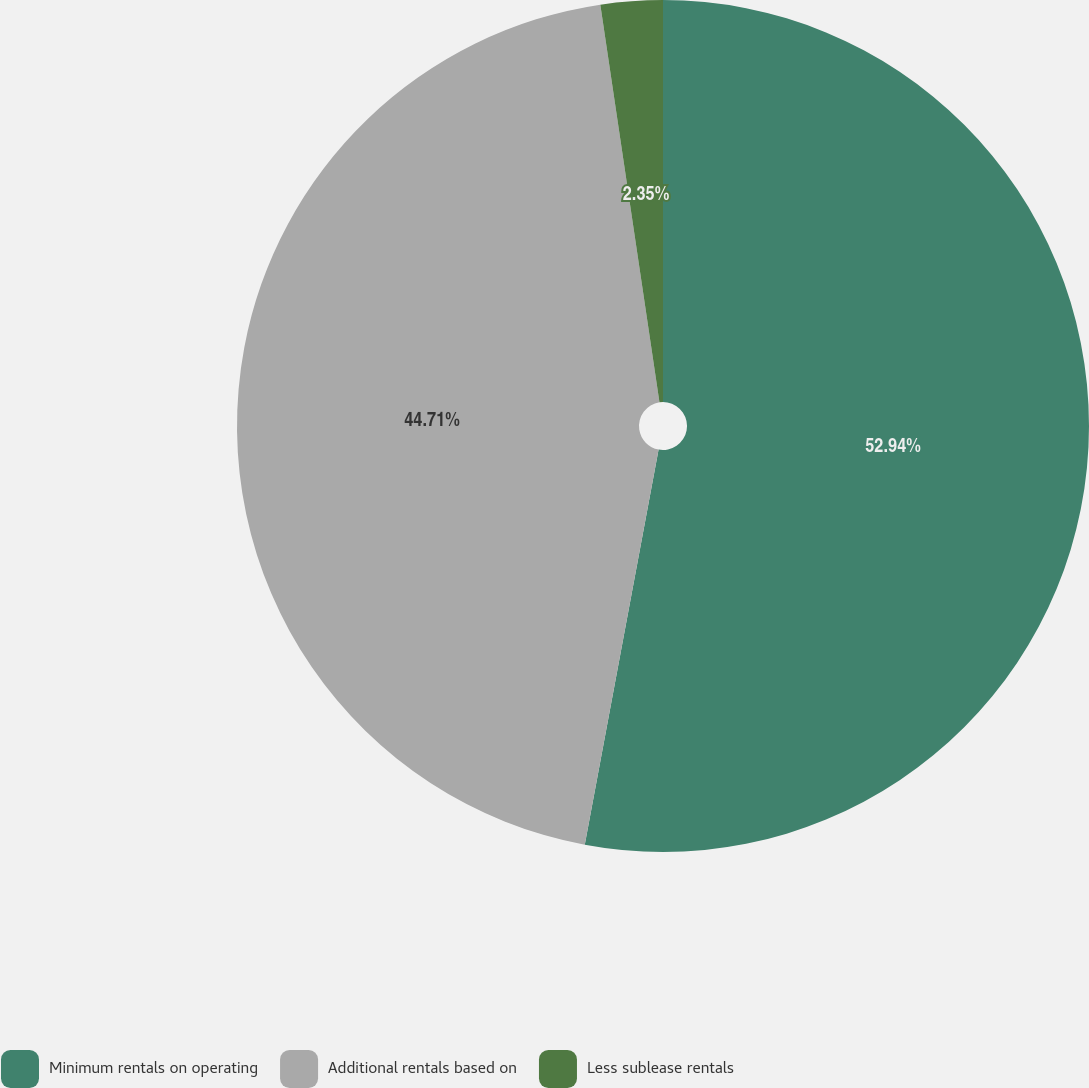Convert chart to OTSL. <chart><loc_0><loc_0><loc_500><loc_500><pie_chart><fcel>Minimum rentals on operating<fcel>Additional rentals based on<fcel>Less sublease rentals<nl><fcel>52.94%<fcel>44.71%<fcel>2.35%<nl></chart> 